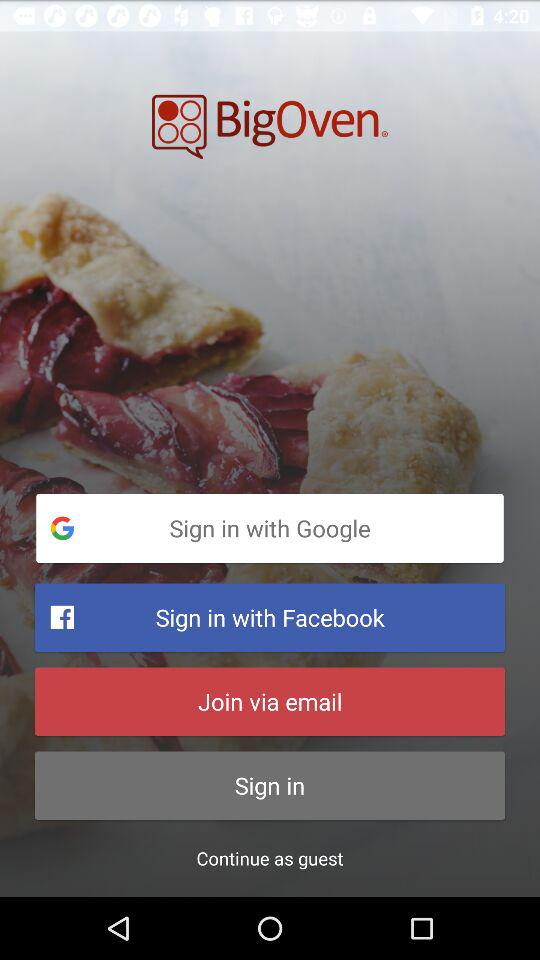Which application can we use to continue? You can use "Google" and "Facebook" to continue. 